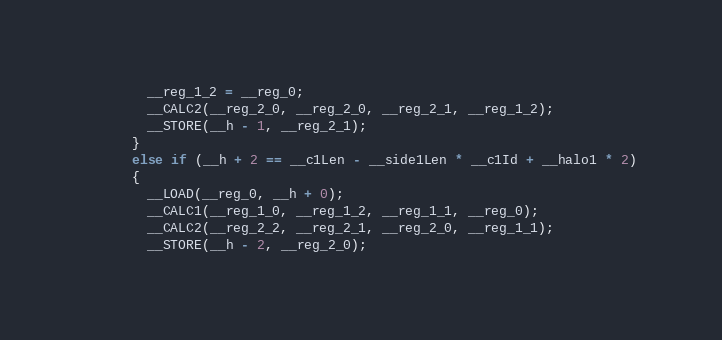Convert code to text. <code><loc_0><loc_0><loc_500><loc_500><_Cuda_>        __reg_1_2 = __reg_0;
        __CALC2(__reg_2_0, __reg_2_0, __reg_2_1, __reg_1_2);
        __STORE(__h - 1, __reg_2_1);
      }
      else if (__h + 2 == __c1Len - __side1Len * __c1Id + __halo1 * 2)
      {
        __LOAD(__reg_0, __h + 0);
        __CALC1(__reg_1_0, __reg_1_2, __reg_1_1, __reg_0);
        __CALC2(__reg_2_2, __reg_2_1, __reg_2_0, __reg_1_1);
        __STORE(__h - 2, __reg_2_0);</code> 